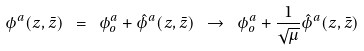Convert formula to latex. <formula><loc_0><loc_0><loc_500><loc_500>\phi ^ { a } ( z , \bar { z } ) \ = \ \phi _ { o } ^ { a } + { \hat { \phi } } ^ { a } ( z , \bar { z } ) \ \rightarrow \ \phi _ { o } ^ { a } + \frac { 1 } { \sqrt { \mu } } { \hat { \phi } } ^ { a } ( z , \bar { z } )</formula> 